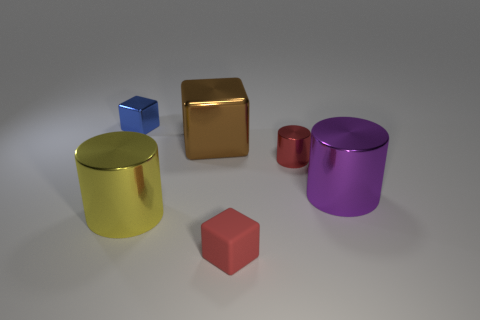There is a large cylinder that is right of the red rubber thing; what is its material?
Offer a terse response. Metal. Is the number of purple metal things that are in front of the big purple metallic thing the same as the number of blue objects that are in front of the matte thing?
Keep it short and to the point. Yes. There is another tiny thing that is the same shape as the matte object; what is its color?
Give a very brief answer. Blue. Is there anything else of the same color as the small shiny cylinder?
Make the answer very short. Yes. What number of rubber objects are either big purple things or small purple blocks?
Provide a short and direct response. 0. Is the rubber block the same color as the small cylinder?
Offer a terse response. Yes. Is the number of yellow metallic cylinders that are in front of the small red matte block greater than the number of metallic objects?
Keep it short and to the point. No. What number of other things are there of the same material as the tiny blue block
Keep it short and to the point. 4. How many large things are either rubber cubes or blue cylinders?
Your response must be concise. 0. Is the material of the tiny red cylinder the same as the tiny blue object?
Offer a terse response. Yes. 